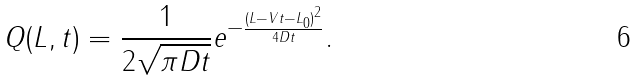<formula> <loc_0><loc_0><loc_500><loc_500>Q ( L , t ) = \frac { 1 } { 2 \sqrt { \pi D t } } e ^ { - \frac { ( L - V t - L _ { 0 } ) ^ { 2 } } { 4 D t } } .</formula> 